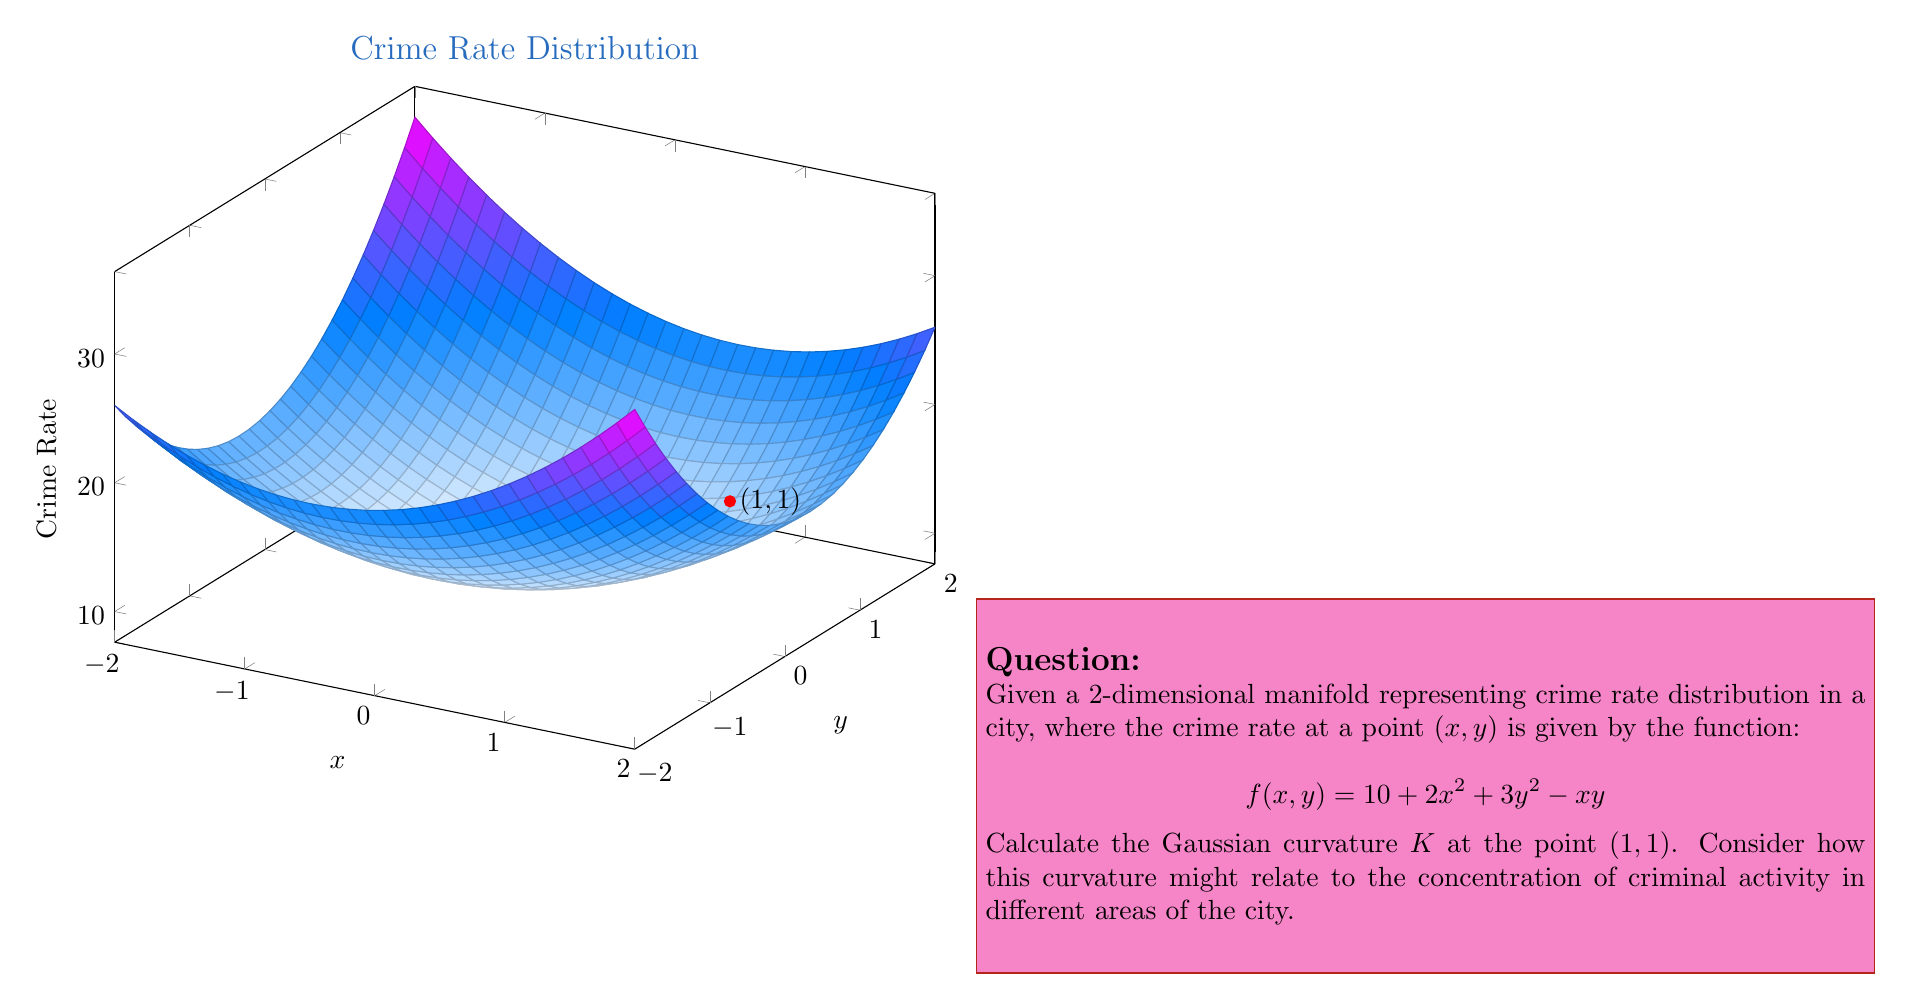Help me with this question. To calculate the Gaussian curvature $K$ at the point $(1,1)$, we need to use the following steps:

1) The Gaussian curvature for a surface $z = f(x,y)$ is given by:

   $$K = \frac{f_{xx}f_{yy} - f_{xy}^2}{(1 + f_x^2 + f_y^2)^2}$$

   where subscripts denote partial derivatives.

2) Calculate the required partial derivatives:
   
   $f_x = 4x - y$
   $f_y = 6y - x$
   $f_{xx} = 4$
   $f_{yy} = 6$
   $f_{xy} = -1$

3) Evaluate these at the point $(1,1)$:
   
   $f_x(1,1) = 4(1) - 1 = 3$
   $f_y(1,1) = 6(1) - 1 = 5$
   $f_{xx}(1,1) = 4$
   $f_{yy}(1,1) = 6$
   $f_{xy}(1,1) = -1$

4) Substitute into the curvature formula:

   $$K = \frac{4 \cdot 6 - (-1)^2}{(1 + 3^2 + 5^2)^2} = \frac{23}{(1 + 9 + 25)^2} = \frac{23}{35^2}$$

5) Simplify:

   $$K = \frac{23}{1225} \approx 0.01878$$

This positive curvature indicates that the crime rate surface is locally convex at $(1,1)$, suggesting a concentration of criminal activity in this area relative to its immediate surroundings.
Answer: $K = \frac{23}{1225}$ 